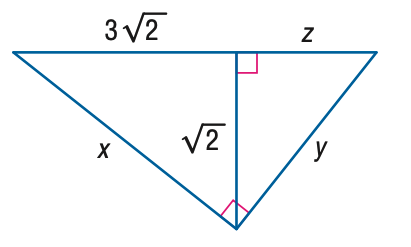Question: Find z.
Choices:
A. \frac { \sqrt { 2 } } { 3 }
B. \frac { \sqrt { 5 } } { 3 }
C. \sqrt { 2 }
D. \sqrt { 5 }
Answer with the letter. Answer: A Question: Find x.
Choices:
A. 2 \sqrt { 2 }
B. 3 \sqrt { 2 }
C. 2 \sqrt { 5 }
D. 3 \sqrt { 5 }
Answer with the letter. Answer: C Question: Find y.
Choices:
A. \frac { 2 } { 3 } \sqrt { 2 }
B. \frac { 2 } { 3 } \sqrt { 5 }
C. 2 \sqrt { 2 }
D. 2 \sqrt { 5 }
Answer with the letter. Answer: B 